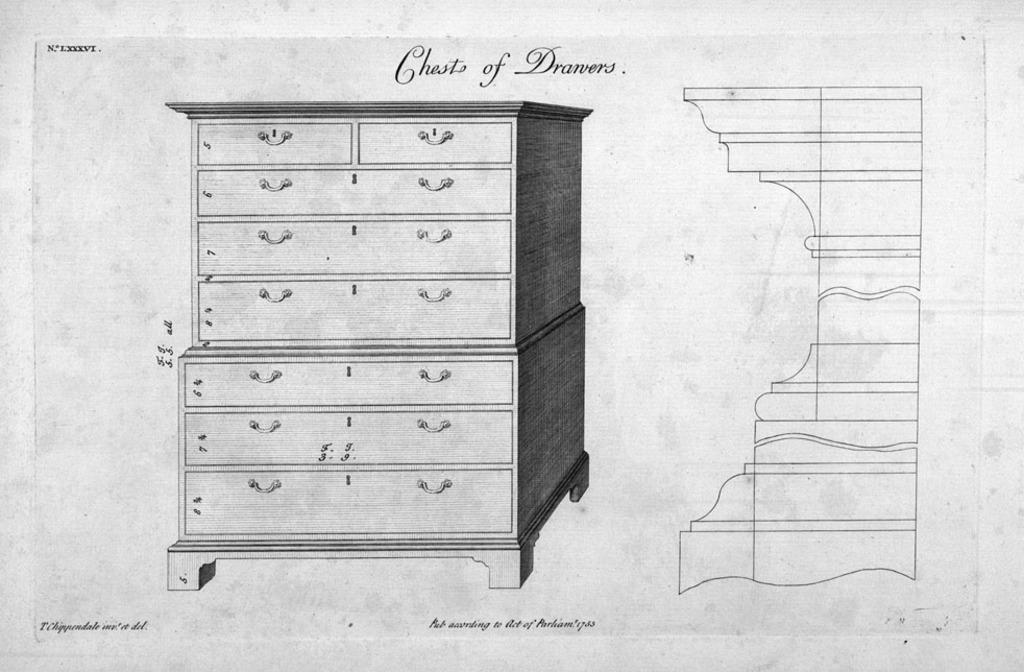Describe this image in one or two sentences. In this image I can see a sketch of a cupboard and something written on the image. The image is black and white in color. 